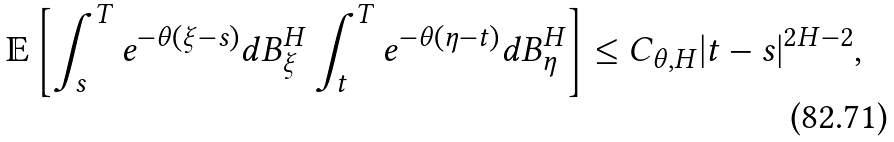Convert formula to latex. <formula><loc_0><loc_0><loc_500><loc_500>\mathbb { E } \left [ \int _ { s } ^ { T } e ^ { - \theta ( \xi - s ) } d B _ { \xi } ^ { H } \int _ { t } ^ { T } e ^ { - \theta ( \eta - t ) } d B _ { \eta } ^ { H } \right ] \leq C _ { \theta , H } | t - s | ^ { 2 H - 2 } ,</formula> 